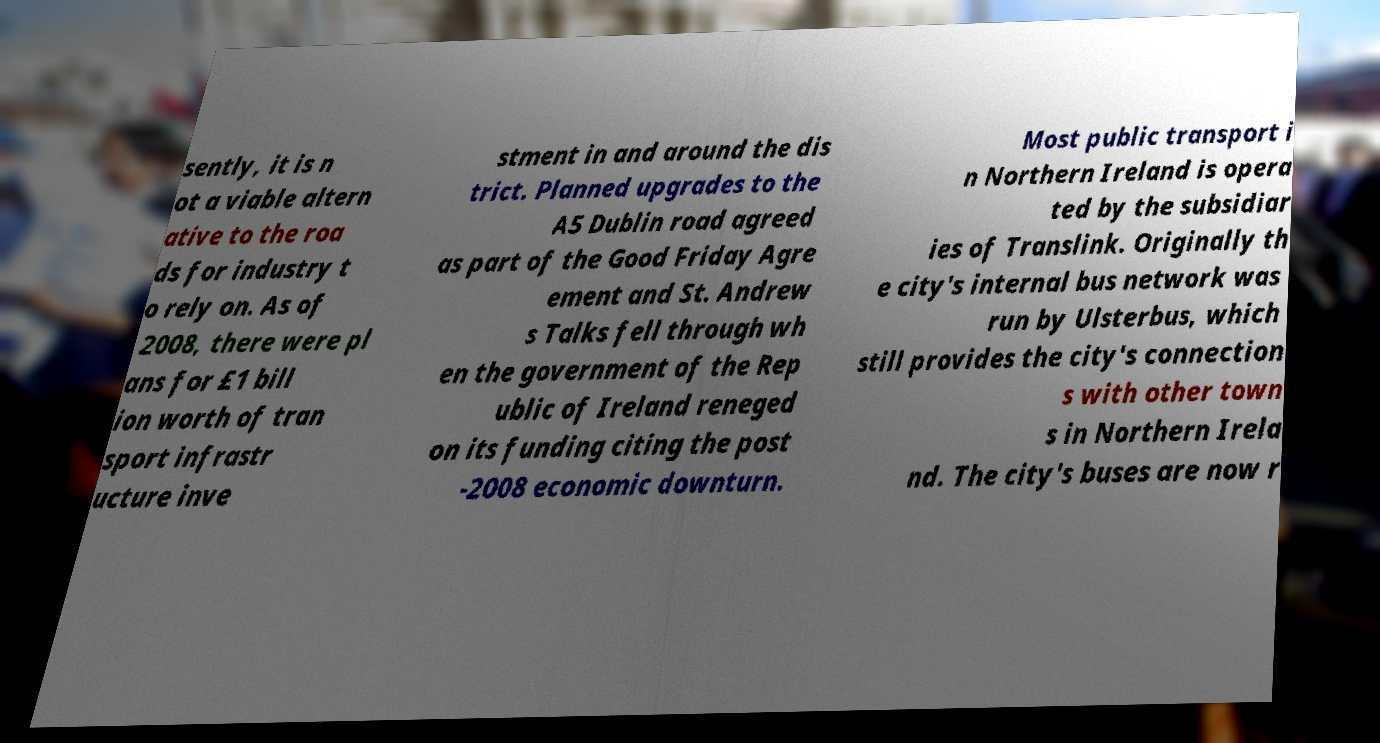Please identify and transcribe the text found in this image. sently, it is n ot a viable altern ative to the roa ds for industry t o rely on. As of 2008, there were pl ans for £1 bill ion worth of tran sport infrastr ucture inve stment in and around the dis trict. Planned upgrades to the A5 Dublin road agreed as part of the Good Friday Agre ement and St. Andrew s Talks fell through wh en the government of the Rep ublic of Ireland reneged on its funding citing the post -2008 economic downturn. Most public transport i n Northern Ireland is opera ted by the subsidiar ies of Translink. Originally th e city's internal bus network was run by Ulsterbus, which still provides the city's connection s with other town s in Northern Irela nd. The city's buses are now r 